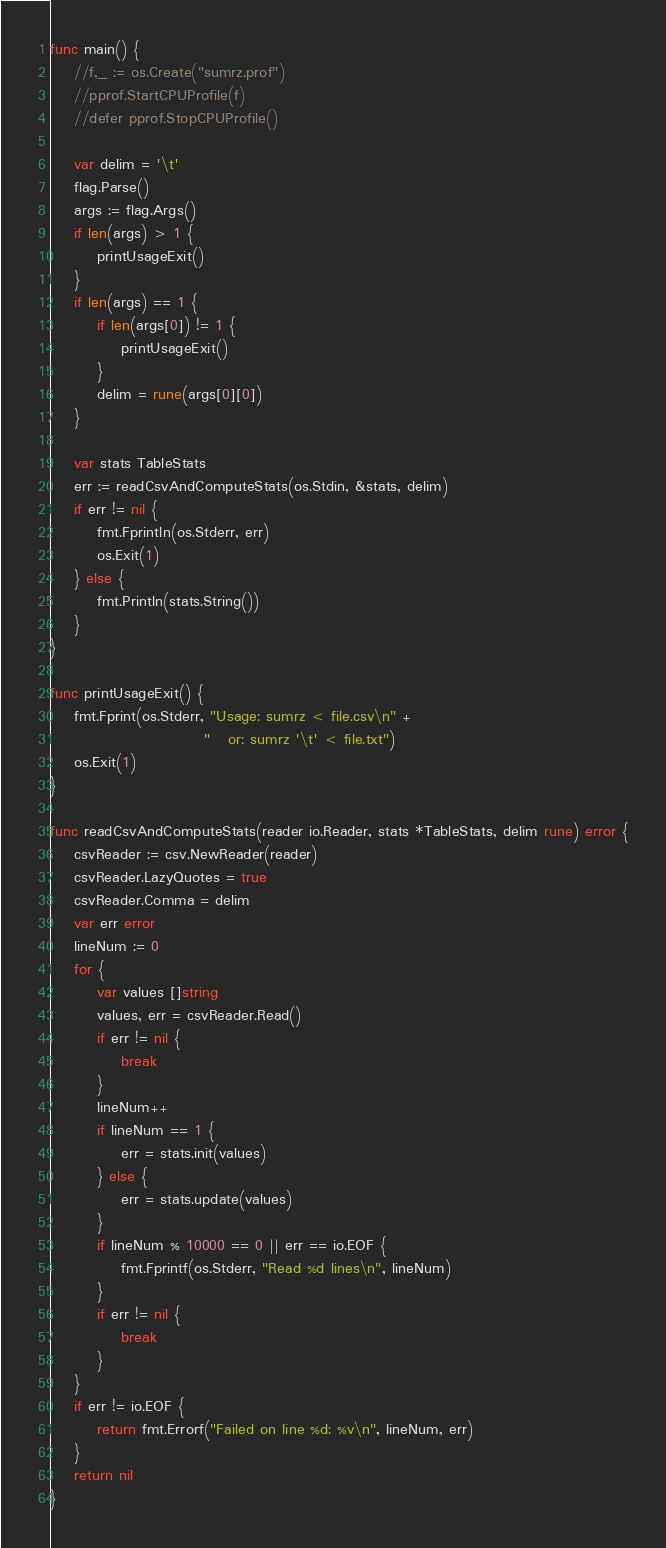Convert code to text. <code><loc_0><loc_0><loc_500><loc_500><_Go_>func main() {
    //f,_ := os.Create("sumrz.prof")
    //pprof.StartCPUProfile(f)
    //defer pprof.StopCPUProfile()

    var delim = '\t'
    flag.Parse()
    args := flag.Args()
    if len(args) > 1 {
        printUsageExit()
    }
    if len(args) == 1 {
        if len(args[0]) != 1 {
            printUsageExit()
        }
        delim = rune(args[0][0])
    }

    var stats TableStats
    err := readCsvAndComputeStats(os.Stdin, &stats, delim)
    if err != nil {
        fmt.Fprintln(os.Stderr, err)
        os.Exit(1)
    } else {
        fmt.Println(stats.String())
    }
}

func printUsageExit() {
    fmt.Fprint(os.Stderr, "Usage: sumrz < file.csv\n" +
                          "   or: sumrz '\t' < file.txt")
    os.Exit(1)
}

func readCsvAndComputeStats(reader io.Reader, stats *TableStats, delim rune) error {
    csvReader := csv.NewReader(reader)
    csvReader.LazyQuotes = true
    csvReader.Comma = delim
    var err error
    lineNum := 0
    for {
        var values []string
        values, err = csvReader.Read()
        if err != nil {
            break
        }
        lineNum++
        if lineNum == 1 {
            err = stats.init(values)
        } else {
            err = stats.update(values)
        }
        if lineNum % 10000 == 0 || err == io.EOF {
            fmt.Fprintf(os.Stderr, "Read %d lines\n", lineNum)
        }
        if err != nil {
            break
        }
    }
    if err != io.EOF {
        return fmt.Errorf("Failed on line %d: %v\n", lineNum, err)
    }
    return nil
}

</code> 